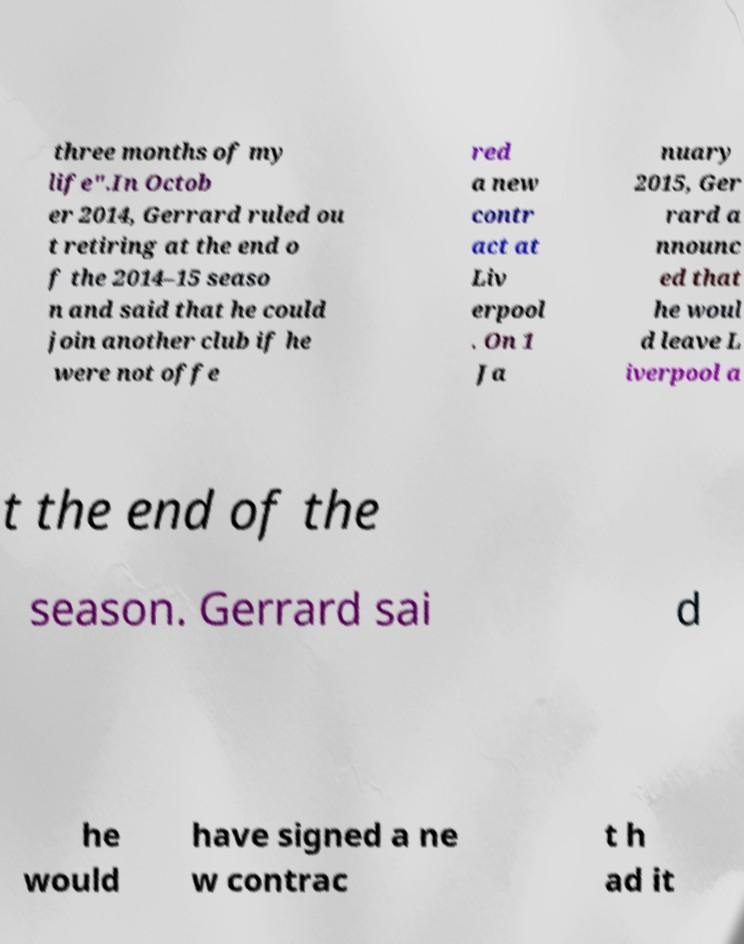Could you assist in decoding the text presented in this image and type it out clearly? three months of my life".In Octob er 2014, Gerrard ruled ou t retiring at the end o f the 2014–15 seaso n and said that he could join another club if he were not offe red a new contr act at Liv erpool . On 1 Ja nuary 2015, Ger rard a nnounc ed that he woul d leave L iverpool a t the end of the season. Gerrard sai d he would have signed a ne w contrac t h ad it 